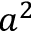<formula> <loc_0><loc_0><loc_500><loc_500>a ^ { 2 }</formula> 